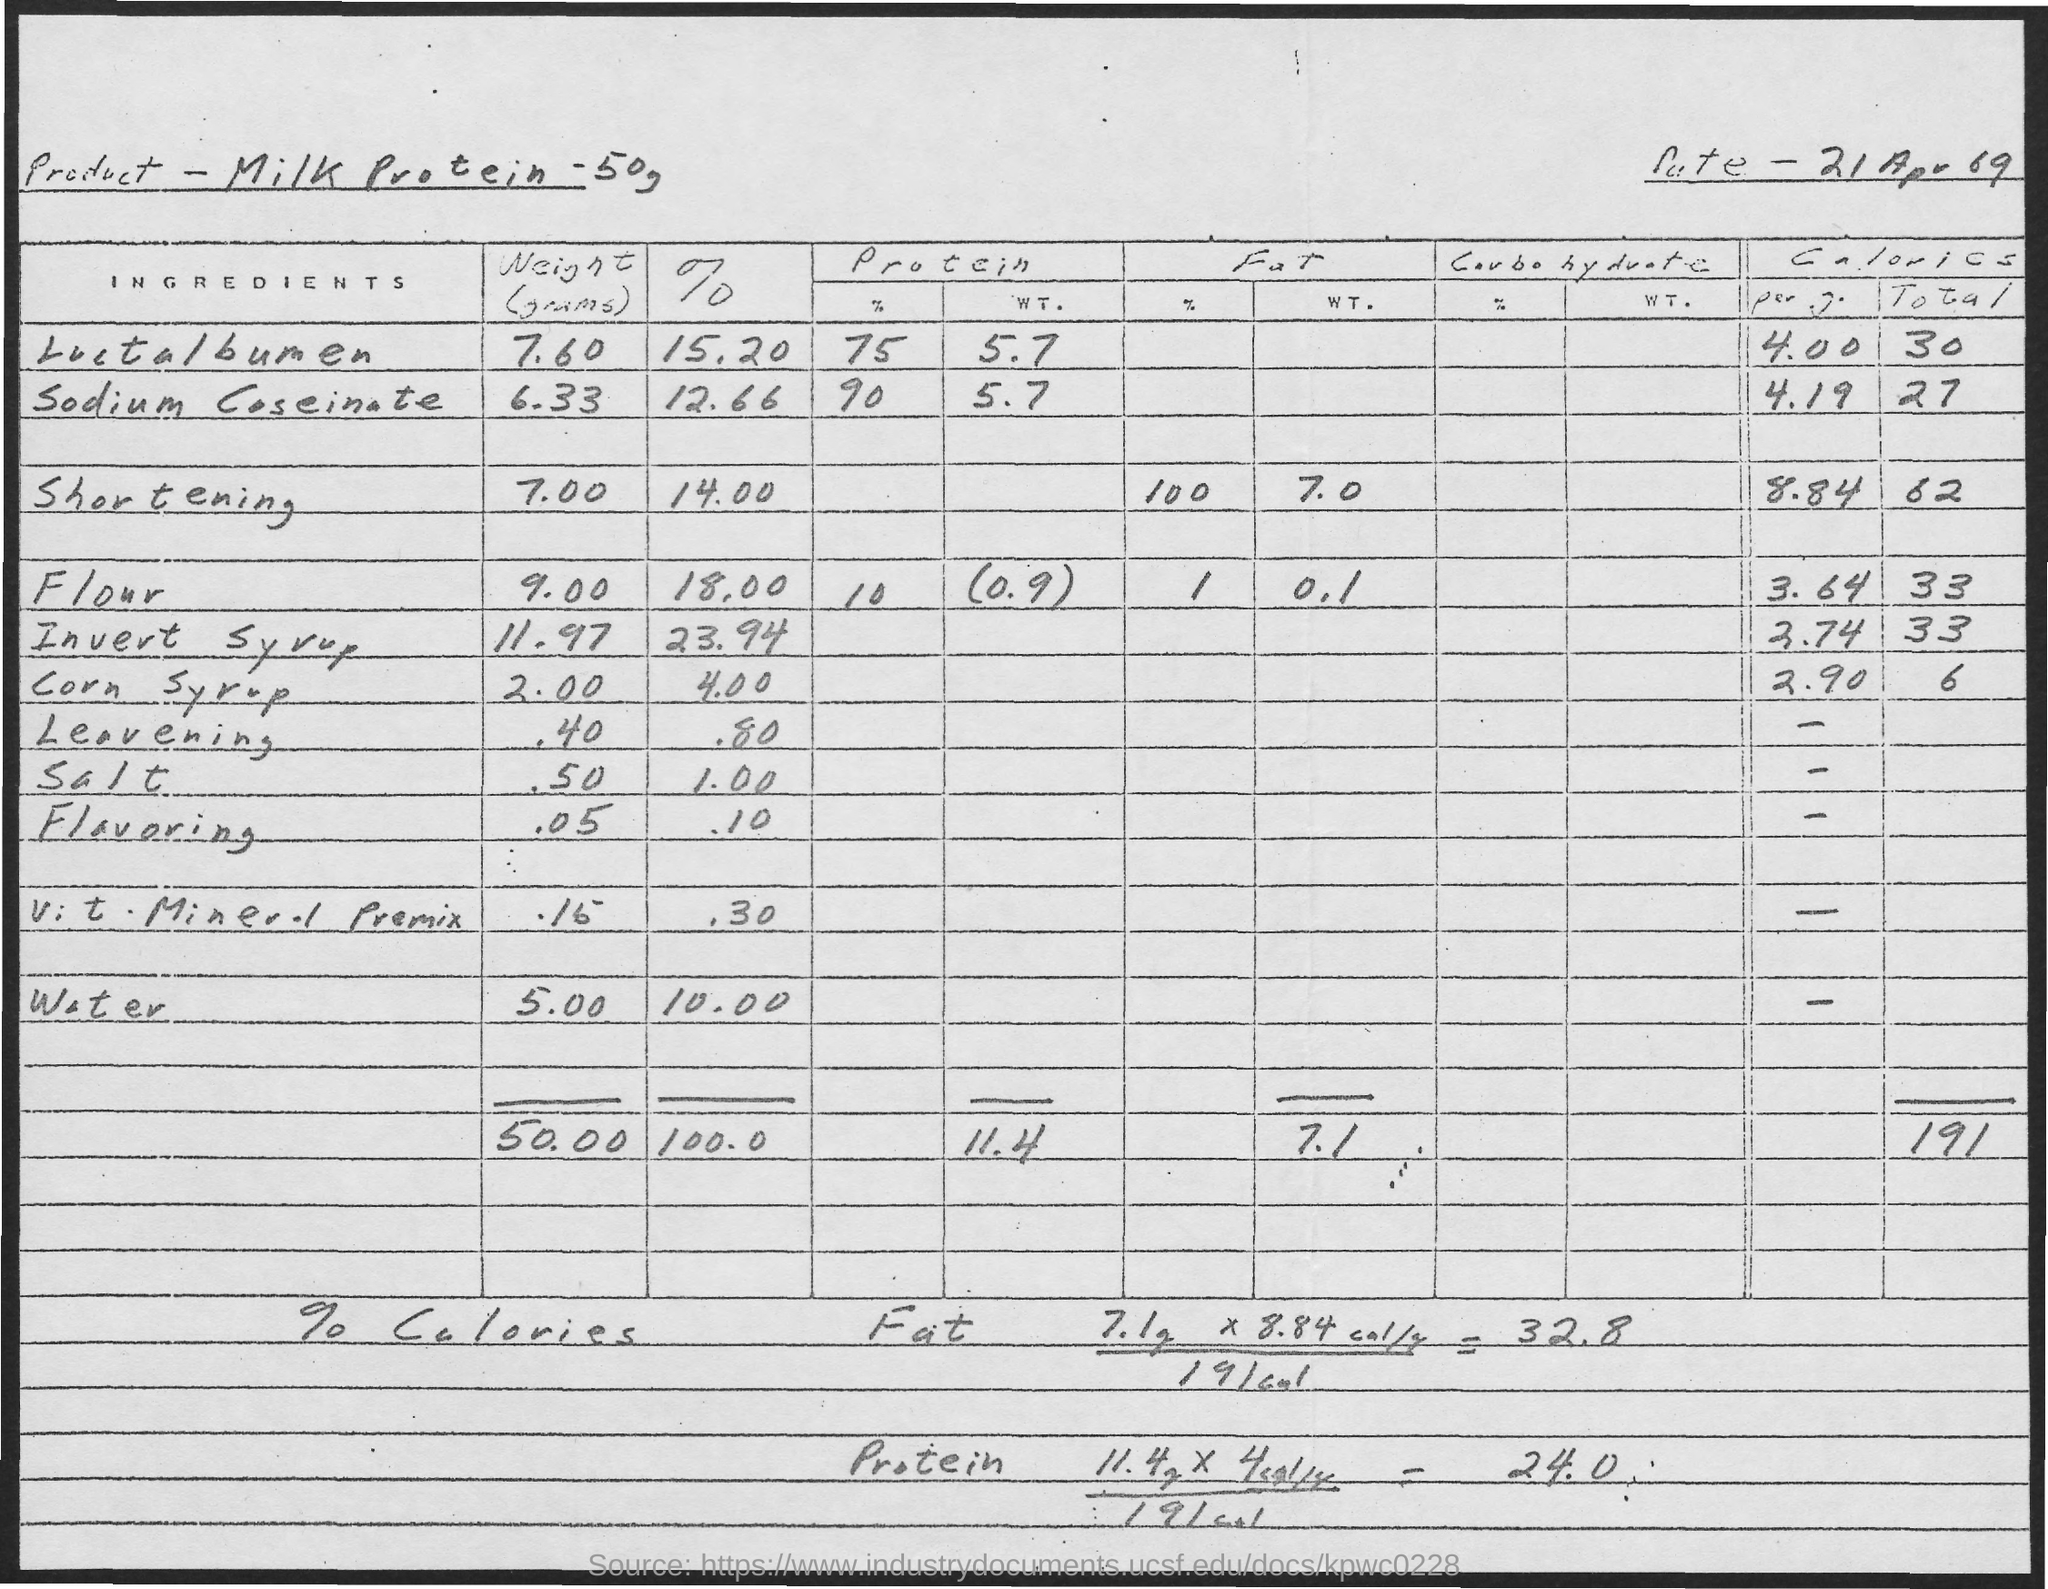What does the total weight at the bottom of the document represent? The total weight at the bottom of the document adds up to 50.00 grams, which likely represents the aggregate weight of all the ingredients listed above it, compiled to create a standard batch or serving size of the product being formulated. 